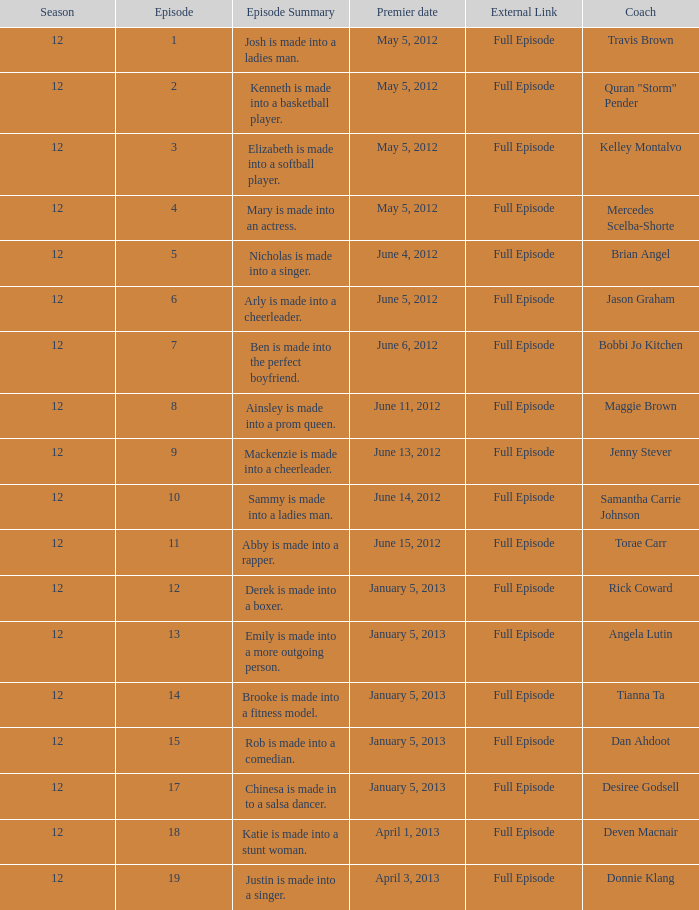Parse the table in full. {'header': ['Season', 'Episode', 'Episode Summary', 'Premier date', 'External Link', 'Coach'], 'rows': [['12', '1', 'Josh is made into a ladies man.', 'May 5, 2012', 'Full Episode', 'Travis Brown'], ['12', '2', 'Kenneth is made into a basketball player.', 'May 5, 2012', 'Full Episode', 'Quran "Storm" Pender'], ['12', '3', 'Elizabeth is made into a softball player.', 'May 5, 2012', 'Full Episode', 'Kelley Montalvo'], ['12', '4', 'Mary is made into an actress.', 'May 5, 2012', 'Full Episode', 'Mercedes Scelba-Shorte'], ['12', '5', 'Nicholas is made into a singer.', 'June 4, 2012', 'Full Episode', 'Brian Angel'], ['12', '6', 'Arly is made into a cheerleader.', 'June 5, 2012', 'Full Episode', 'Jason Graham'], ['12', '7', 'Ben is made into the perfect boyfriend.', 'June 6, 2012', 'Full Episode', 'Bobbi Jo Kitchen'], ['12', '8', 'Ainsley is made into a prom queen.', 'June 11, 2012', 'Full Episode', 'Maggie Brown'], ['12', '9', 'Mackenzie is made into a cheerleader.', 'June 13, 2012', 'Full Episode', 'Jenny Stever'], ['12', '10', 'Sammy is made into a ladies man.', 'June 14, 2012', 'Full Episode', 'Samantha Carrie Johnson'], ['12', '11', 'Abby is made into a rapper.', 'June 15, 2012', 'Full Episode', 'Torae Carr'], ['12', '12', 'Derek is made into a boxer.', 'January 5, 2013', 'Full Episode', 'Rick Coward'], ['12', '13', 'Emily is made into a more outgoing person.', 'January 5, 2013', 'Full Episode', 'Angela Lutin'], ['12', '14', 'Brooke is made into a fitness model.', 'January 5, 2013', 'Full Episode', 'Tianna Ta'], ['12', '15', 'Rob is made into a comedian.', 'January 5, 2013', 'Full Episode', 'Dan Ahdoot'], ['12', '17', 'Chinesa is made in to a salsa dancer.', 'January 5, 2013', 'Full Episode', 'Desiree Godsell'], ['12', '18', 'Katie is made into a stunt woman.', 'April 1, 2013', 'Full Episode', 'Deven Macnair'], ['12', '19', 'Justin is made into a singer.', 'April 3, 2013', 'Full Episode', 'Donnie Klang']]} Name the coach for  emily is made into a more outgoing person. Angela Lutin. 